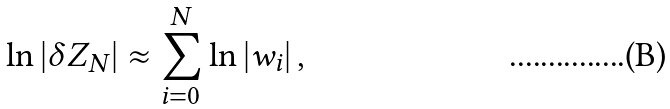Convert formula to latex. <formula><loc_0><loc_0><loc_500><loc_500>\ln | \delta Z _ { N } | \approx \sum _ { i = 0 } ^ { N } \ln \left | w _ { i } \right | ,</formula> 